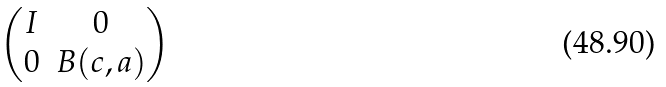<formula> <loc_0><loc_0><loc_500><loc_500>\begin{pmatrix} I & 0 \\ 0 & B ( c , a ) \end{pmatrix}</formula> 